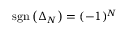Convert formula to latex. <formula><loc_0><loc_0><loc_500><loc_500>s g n \left ( \Delta _ { N } \right ) = ( - 1 ) ^ { N }</formula> 